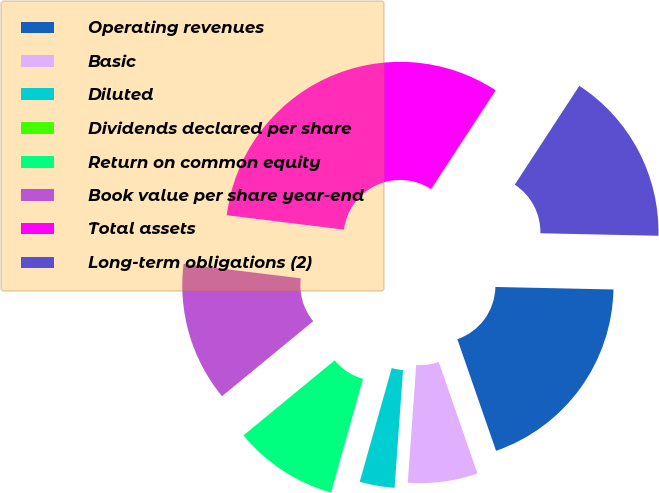<chart> <loc_0><loc_0><loc_500><loc_500><pie_chart><fcel>Operating revenues<fcel>Basic<fcel>Diluted<fcel>Dividends declared per share<fcel>Return on common equity<fcel>Book value per share year-end<fcel>Total assets<fcel>Long-term obligations (2)<nl><fcel>19.35%<fcel>6.45%<fcel>3.23%<fcel>0.0%<fcel>9.68%<fcel>12.9%<fcel>32.26%<fcel>16.13%<nl></chart> 